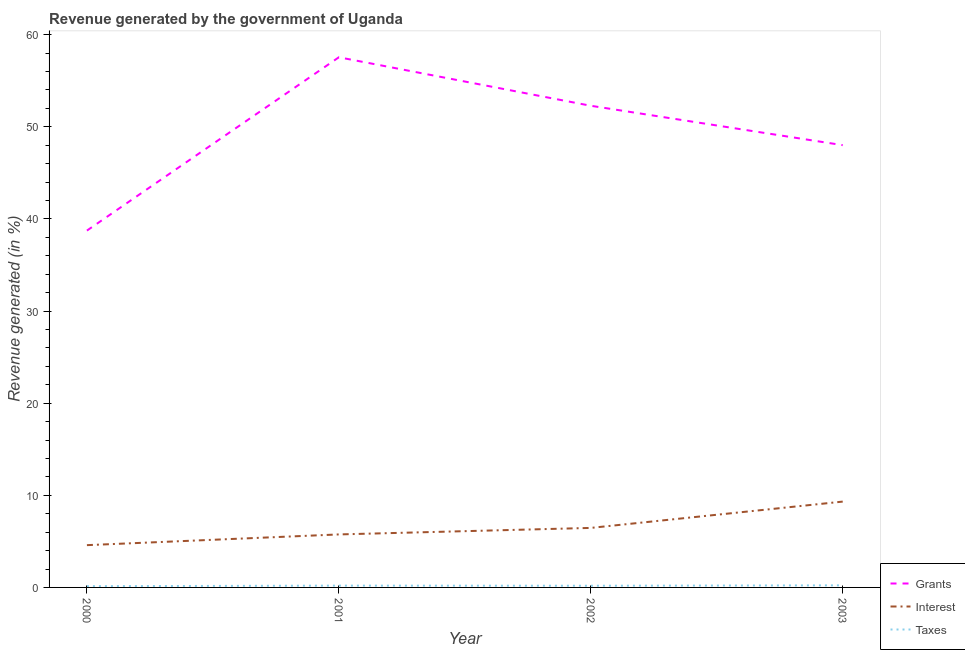How many different coloured lines are there?
Give a very brief answer. 3. Does the line corresponding to percentage of revenue generated by interest intersect with the line corresponding to percentage of revenue generated by grants?
Keep it short and to the point. No. Is the number of lines equal to the number of legend labels?
Ensure brevity in your answer.  Yes. What is the percentage of revenue generated by taxes in 2003?
Your answer should be very brief. 0.22. Across all years, what is the maximum percentage of revenue generated by grants?
Provide a succinct answer. 57.55. Across all years, what is the minimum percentage of revenue generated by interest?
Provide a succinct answer. 4.59. What is the total percentage of revenue generated by interest in the graph?
Your answer should be compact. 26.12. What is the difference between the percentage of revenue generated by grants in 2001 and that in 2003?
Provide a succinct answer. 9.54. What is the difference between the percentage of revenue generated by interest in 2001 and the percentage of revenue generated by grants in 2002?
Ensure brevity in your answer.  -46.53. What is the average percentage of revenue generated by interest per year?
Ensure brevity in your answer.  6.53. In the year 2000, what is the difference between the percentage of revenue generated by interest and percentage of revenue generated by taxes?
Ensure brevity in your answer.  4.45. What is the ratio of the percentage of revenue generated by grants in 2000 to that in 2002?
Keep it short and to the point. 0.74. Is the percentage of revenue generated by grants in 2001 less than that in 2003?
Your response must be concise. No. What is the difference between the highest and the second highest percentage of revenue generated by grants?
Keep it short and to the point. 5.26. What is the difference between the highest and the lowest percentage of revenue generated by taxes?
Provide a short and direct response. 0.09. Is the sum of the percentage of revenue generated by taxes in 2000 and 2002 greater than the maximum percentage of revenue generated by interest across all years?
Ensure brevity in your answer.  No. Is it the case that in every year, the sum of the percentage of revenue generated by grants and percentage of revenue generated by interest is greater than the percentage of revenue generated by taxes?
Ensure brevity in your answer.  Yes. Does the percentage of revenue generated by interest monotonically increase over the years?
Ensure brevity in your answer.  Yes. How many lines are there?
Make the answer very short. 3. How many years are there in the graph?
Your response must be concise. 4. Does the graph contain any zero values?
Your response must be concise. No. Where does the legend appear in the graph?
Ensure brevity in your answer.  Bottom right. How many legend labels are there?
Your answer should be very brief. 3. What is the title of the graph?
Provide a short and direct response. Revenue generated by the government of Uganda. Does "Non-communicable diseases" appear as one of the legend labels in the graph?
Ensure brevity in your answer.  No. What is the label or title of the X-axis?
Your response must be concise. Year. What is the label or title of the Y-axis?
Offer a terse response. Revenue generated (in %). What is the Revenue generated (in %) in Grants in 2000?
Make the answer very short. 38.73. What is the Revenue generated (in %) of Interest in 2000?
Provide a succinct answer. 4.59. What is the Revenue generated (in %) of Taxes in 2000?
Your answer should be very brief. 0.14. What is the Revenue generated (in %) of Grants in 2001?
Keep it short and to the point. 57.55. What is the Revenue generated (in %) in Interest in 2001?
Give a very brief answer. 5.75. What is the Revenue generated (in %) in Taxes in 2001?
Provide a short and direct response. 0.2. What is the Revenue generated (in %) in Grants in 2002?
Keep it short and to the point. 52.28. What is the Revenue generated (in %) of Interest in 2002?
Offer a very short reply. 6.46. What is the Revenue generated (in %) in Taxes in 2002?
Your answer should be compact. 0.18. What is the Revenue generated (in %) in Grants in 2003?
Your answer should be very brief. 48.01. What is the Revenue generated (in %) of Interest in 2003?
Keep it short and to the point. 9.32. What is the Revenue generated (in %) of Taxes in 2003?
Ensure brevity in your answer.  0.22. Across all years, what is the maximum Revenue generated (in %) in Grants?
Ensure brevity in your answer.  57.55. Across all years, what is the maximum Revenue generated (in %) in Interest?
Ensure brevity in your answer.  9.32. Across all years, what is the maximum Revenue generated (in %) in Taxes?
Your answer should be compact. 0.22. Across all years, what is the minimum Revenue generated (in %) in Grants?
Your response must be concise. 38.73. Across all years, what is the minimum Revenue generated (in %) of Interest?
Give a very brief answer. 4.59. Across all years, what is the minimum Revenue generated (in %) of Taxes?
Make the answer very short. 0.14. What is the total Revenue generated (in %) in Grants in the graph?
Your answer should be very brief. 196.57. What is the total Revenue generated (in %) of Interest in the graph?
Your response must be concise. 26.12. What is the total Revenue generated (in %) of Taxes in the graph?
Your response must be concise. 0.74. What is the difference between the Revenue generated (in %) in Grants in 2000 and that in 2001?
Offer a very short reply. -18.81. What is the difference between the Revenue generated (in %) in Interest in 2000 and that in 2001?
Provide a short and direct response. -1.16. What is the difference between the Revenue generated (in %) in Taxes in 2000 and that in 2001?
Provide a succinct answer. -0.06. What is the difference between the Revenue generated (in %) of Grants in 2000 and that in 2002?
Make the answer very short. -13.55. What is the difference between the Revenue generated (in %) of Interest in 2000 and that in 2002?
Make the answer very short. -1.87. What is the difference between the Revenue generated (in %) in Taxes in 2000 and that in 2002?
Give a very brief answer. -0.05. What is the difference between the Revenue generated (in %) of Grants in 2000 and that in 2003?
Your answer should be very brief. -9.27. What is the difference between the Revenue generated (in %) in Interest in 2000 and that in 2003?
Offer a very short reply. -4.73. What is the difference between the Revenue generated (in %) of Taxes in 2000 and that in 2003?
Your answer should be compact. -0.09. What is the difference between the Revenue generated (in %) of Grants in 2001 and that in 2002?
Offer a very short reply. 5.26. What is the difference between the Revenue generated (in %) in Interest in 2001 and that in 2002?
Offer a very short reply. -0.71. What is the difference between the Revenue generated (in %) of Taxes in 2001 and that in 2002?
Your answer should be very brief. 0.01. What is the difference between the Revenue generated (in %) in Grants in 2001 and that in 2003?
Offer a very short reply. 9.54. What is the difference between the Revenue generated (in %) in Interest in 2001 and that in 2003?
Provide a succinct answer. -3.56. What is the difference between the Revenue generated (in %) in Taxes in 2001 and that in 2003?
Your answer should be compact. -0.03. What is the difference between the Revenue generated (in %) of Grants in 2002 and that in 2003?
Offer a very short reply. 4.28. What is the difference between the Revenue generated (in %) in Interest in 2002 and that in 2003?
Ensure brevity in your answer.  -2.86. What is the difference between the Revenue generated (in %) of Taxes in 2002 and that in 2003?
Offer a very short reply. -0.04. What is the difference between the Revenue generated (in %) in Grants in 2000 and the Revenue generated (in %) in Interest in 2001?
Make the answer very short. 32.98. What is the difference between the Revenue generated (in %) of Grants in 2000 and the Revenue generated (in %) of Taxes in 2001?
Your answer should be compact. 38.54. What is the difference between the Revenue generated (in %) of Interest in 2000 and the Revenue generated (in %) of Taxes in 2001?
Give a very brief answer. 4.39. What is the difference between the Revenue generated (in %) of Grants in 2000 and the Revenue generated (in %) of Interest in 2002?
Provide a succinct answer. 32.27. What is the difference between the Revenue generated (in %) of Grants in 2000 and the Revenue generated (in %) of Taxes in 2002?
Your answer should be very brief. 38.55. What is the difference between the Revenue generated (in %) in Interest in 2000 and the Revenue generated (in %) in Taxes in 2002?
Your answer should be compact. 4.41. What is the difference between the Revenue generated (in %) in Grants in 2000 and the Revenue generated (in %) in Interest in 2003?
Offer a terse response. 29.42. What is the difference between the Revenue generated (in %) in Grants in 2000 and the Revenue generated (in %) in Taxes in 2003?
Give a very brief answer. 38.51. What is the difference between the Revenue generated (in %) in Interest in 2000 and the Revenue generated (in %) in Taxes in 2003?
Give a very brief answer. 4.36. What is the difference between the Revenue generated (in %) in Grants in 2001 and the Revenue generated (in %) in Interest in 2002?
Your response must be concise. 51.09. What is the difference between the Revenue generated (in %) in Grants in 2001 and the Revenue generated (in %) in Taxes in 2002?
Give a very brief answer. 57.36. What is the difference between the Revenue generated (in %) in Interest in 2001 and the Revenue generated (in %) in Taxes in 2002?
Provide a short and direct response. 5.57. What is the difference between the Revenue generated (in %) in Grants in 2001 and the Revenue generated (in %) in Interest in 2003?
Your answer should be compact. 48.23. What is the difference between the Revenue generated (in %) of Grants in 2001 and the Revenue generated (in %) of Taxes in 2003?
Provide a short and direct response. 57.32. What is the difference between the Revenue generated (in %) of Interest in 2001 and the Revenue generated (in %) of Taxes in 2003?
Your answer should be compact. 5.53. What is the difference between the Revenue generated (in %) of Grants in 2002 and the Revenue generated (in %) of Interest in 2003?
Your answer should be very brief. 42.97. What is the difference between the Revenue generated (in %) of Grants in 2002 and the Revenue generated (in %) of Taxes in 2003?
Make the answer very short. 52.06. What is the difference between the Revenue generated (in %) in Interest in 2002 and the Revenue generated (in %) in Taxes in 2003?
Your answer should be compact. 6.24. What is the average Revenue generated (in %) of Grants per year?
Keep it short and to the point. 49.14. What is the average Revenue generated (in %) of Interest per year?
Offer a very short reply. 6.53. What is the average Revenue generated (in %) in Taxes per year?
Keep it short and to the point. 0.19. In the year 2000, what is the difference between the Revenue generated (in %) in Grants and Revenue generated (in %) in Interest?
Keep it short and to the point. 34.14. In the year 2000, what is the difference between the Revenue generated (in %) in Grants and Revenue generated (in %) in Taxes?
Make the answer very short. 38.6. In the year 2000, what is the difference between the Revenue generated (in %) in Interest and Revenue generated (in %) in Taxes?
Your answer should be compact. 4.45. In the year 2001, what is the difference between the Revenue generated (in %) of Grants and Revenue generated (in %) of Interest?
Keep it short and to the point. 51.79. In the year 2001, what is the difference between the Revenue generated (in %) of Grants and Revenue generated (in %) of Taxes?
Your answer should be very brief. 57.35. In the year 2001, what is the difference between the Revenue generated (in %) of Interest and Revenue generated (in %) of Taxes?
Your answer should be very brief. 5.56. In the year 2002, what is the difference between the Revenue generated (in %) of Grants and Revenue generated (in %) of Interest?
Make the answer very short. 45.82. In the year 2002, what is the difference between the Revenue generated (in %) in Grants and Revenue generated (in %) in Taxes?
Offer a very short reply. 52.1. In the year 2002, what is the difference between the Revenue generated (in %) of Interest and Revenue generated (in %) of Taxes?
Offer a terse response. 6.28. In the year 2003, what is the difference between the Revenue generated (in %) of Grants and Revenue generated (in %) of Interest?
Provide a succinct answer. 38.69. In the year 2003, what is the difference between the Revenue generated (in %) in Grants and Revenue generated (in %) in Taxes?
Keep it short and to the point. 47.78. In the year 2003, what is the difference between the Revenue generated (in %) in Interest and Revenue generated (in %) in Taxes?
Your answer should be very brief. 9.09. What is the ratio of the Revenue generated (in %) in Grants in 2000 to that in 2001?
Ensure brevity in your answer.  0.67. What is the ratio of the Revenue generated (in %) in Interest in 2000 to that in 2001?
Give a very brief answer. 0.8. What is the ratio of the Revenue generated (in %) of Taxes in 2000 to that in 2001?
Offer a very short reply. 0.69. What is the ratio of the Revenue generated (in %) of Grants in 2000 to that in 2002?
Offer a terse response. 0.74. What is the ratio of the Revenue generated (in %) in Interest in 2000 to that in 2002?
Keep it short and to the point. 0.71. What is the ratio of the Revenue generated (in %) of Taxes in 2000 to that in 2002?
Keep it short and to the point. 0.73. What is the ratio of the Revenue generated (in %) in Grants in 2000 to that in 2003?
Offer a very short reply. 0.81. What is the ratio of the Revenue generated (in %) in Interest in 2000 to that in 2003?
Your response must be concise. 0.49. What is the ratio of the Revenue generated (in %) of Taxes in 2000 to that in 2003?
Your answer should be very brief. 0.6. What is the ratio of the Revenue generated (in %) in Grants in 2001 to that in 2002?
Offer a terse response. 1.1. What is the ratio of the Revenue generated (in %) of Interest in 2001 to that in 2002?
Keep it short and to the point. 0.89. What is the ratio of the Revenue generated (in %) in Taxes in 2001 to that in 2002?
Offer a very short reply. 1.07. What is the ratio of the Revenue generated (in %) of Grants in 2001 to that in 2003?
Offer a terse response. 1.2. What is the ratio of the Revenue generated (in %) in Interest in 2001 to that in 2003?
Offer a very short reply. 0.62. What is the ratio of the Revenue generated (in %) of Taxes in 2001 to that in 2003?
Keep it short and to the point. 0.88. What is the ratio of the Revenue generated (in %) of Grants in 2002 to that in 2003?
Give a very brief answer. 1.09. What is the ratio of the Revenue generated (in %) in Interest in 2002 to that in 2003?
Offer a terse response. 0.69. What is the ratio of the Revenue generated (in %) in Taxes in 2002 to that in 2003?
Offer a terse response. 0.82. What is the difference between the highest and the second highest Revenue generated (in %) in Grants?
Your answer should be compact. 5.26. What is the difference between the highest and the second highest Revenue generated (in %) of Interest?
Provide a succinct answer. 2.86. What is the difference between the highest and the second highest Revenue generated (in %) in Taxes?
Your answer should be very brief. 0.03. What is the difference between the highest and the lowest Revenue generated (in %) in Grants?
Your answer should be very brief. 18.81. What is the difference between the highest and the lowest Revenue generated (in %) in Interest?
Your response must be concise. 4.73. What is the difference between the highest and the lowest Revenue generated (in %) of Taxes?
Keep it short and to the point. 0.09. 